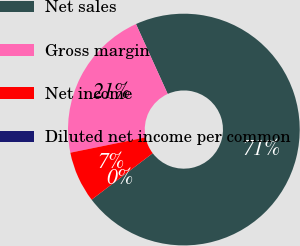Convert chart to OTSL. <chart><loc_0><loc_0><loc_500><loc_500><pie_chart><fcel>Net sales<fcel>Gross margin<fcel>Net income<fcel>Diluted net income per common<nl><fcel>71.44%<fcel>21.42%<fcel>7.14%<fcel>0.0%<nl></chart> 